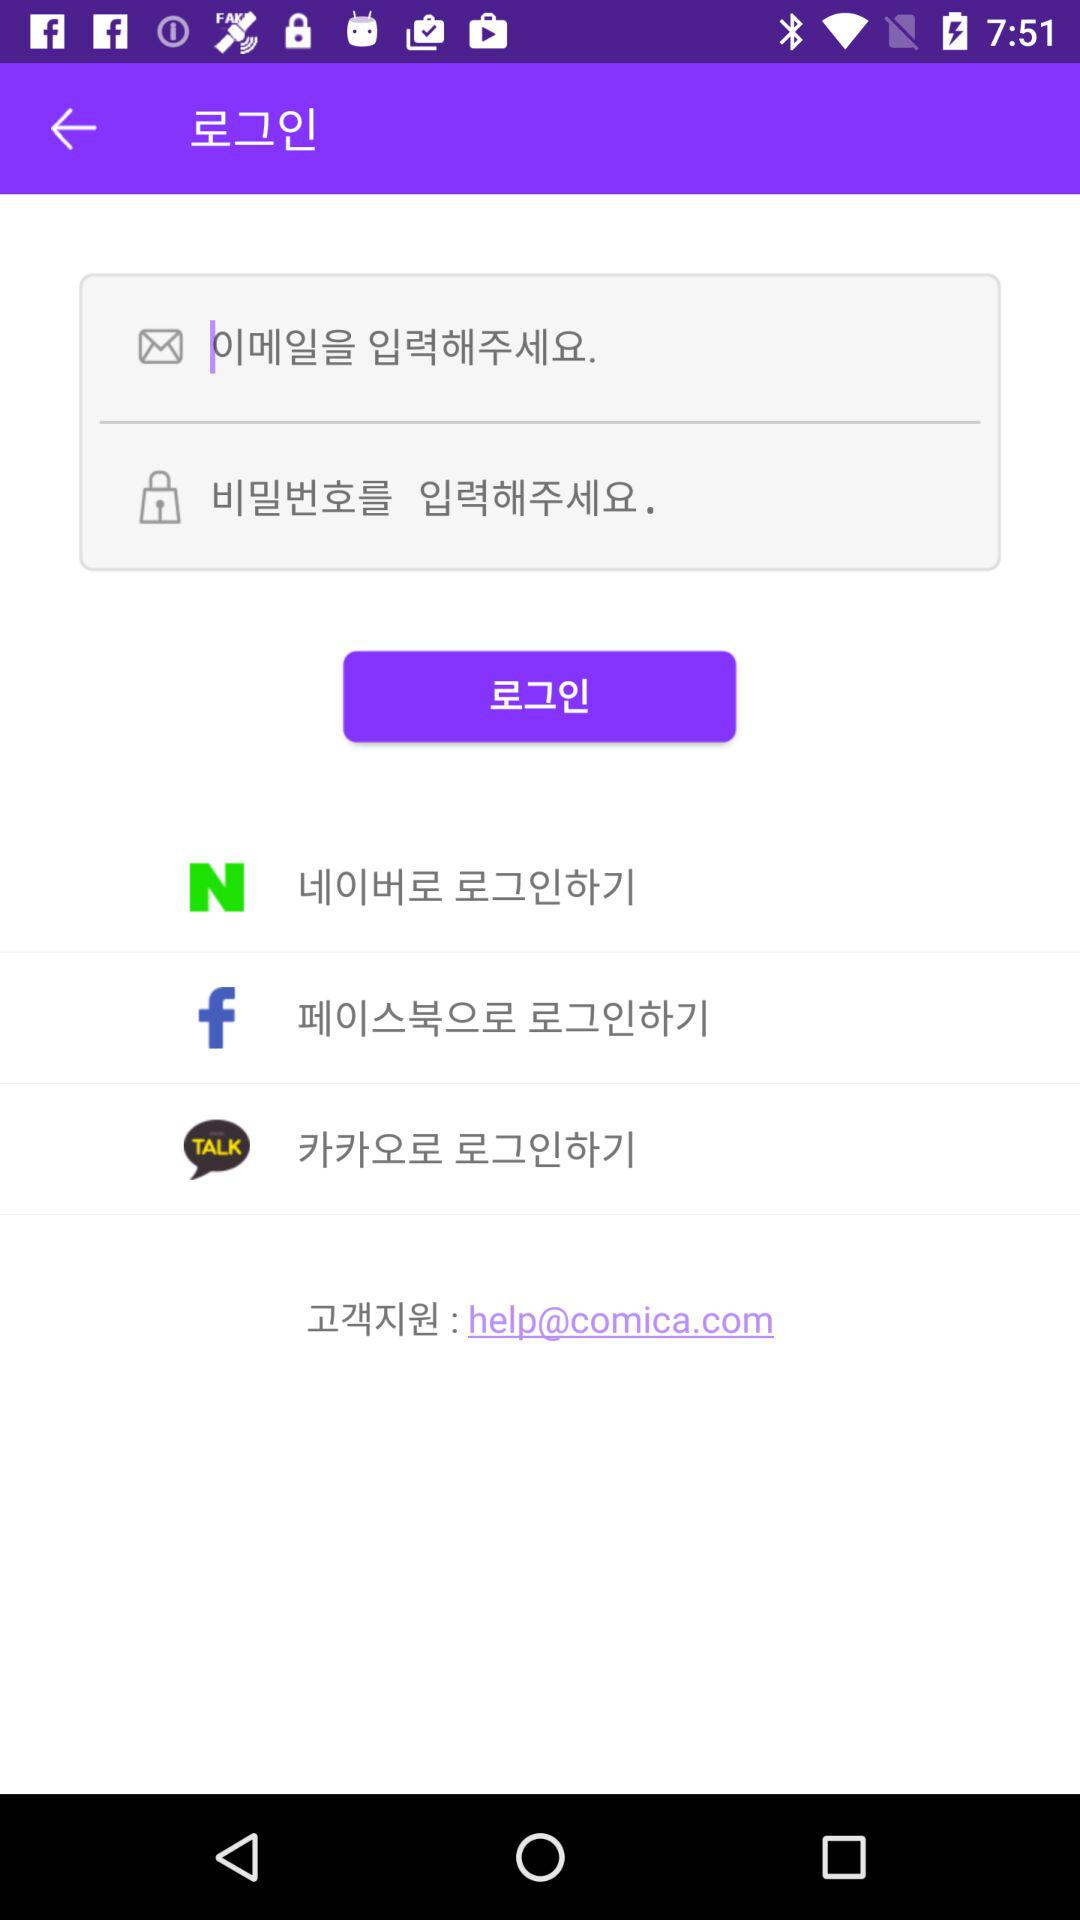How many social login options are there?
Answer the question using a single word or phrase. 3 